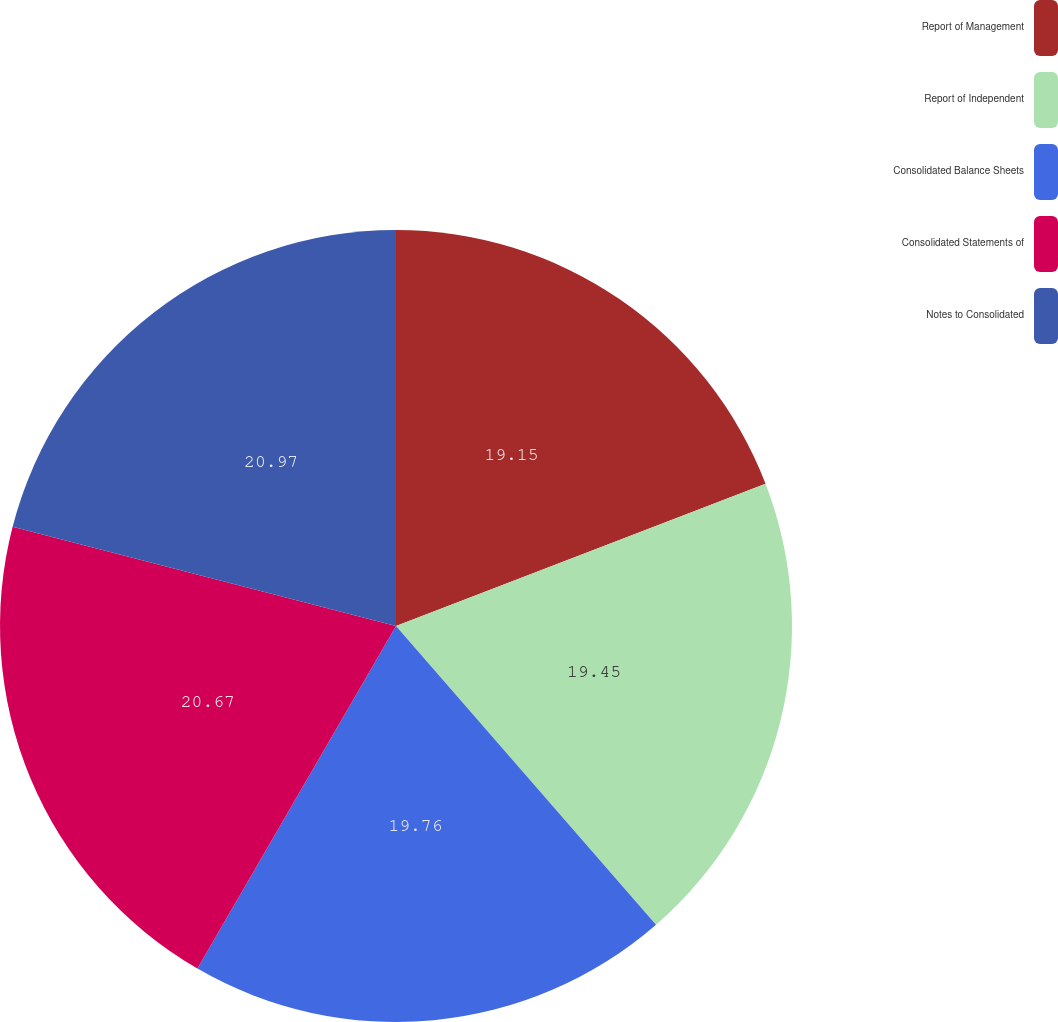<chart> <loc_0><loc_0><loc_500><loc_500><pie_chart><fcel>Report of Management<fcel>Report of Independent<fcel>Consolidated Balance Sheets<fcel>Consolidated Statements of<fcel>Notes to Consolidated<nl><fcel>19.15%<fcel>19.45%<fcel>19.76%<fcel>20.67%<fcel>20.97%<nl></chart> 